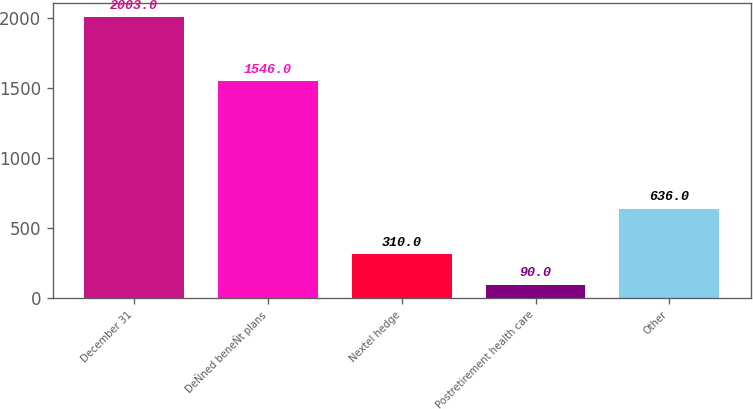Convert chart to OTSL. <chart><loc_0><loc_0><loc_500><loc_500><bar_chart><fcel>December 31<fcel>DeÑned beneÑt plans<fcel>Nextel hedge<fcel>Postretirement health care<fcel>Other<nl><fcel>2003<fcel>1546<fcel>310<fcel>90<fcel>636<nl></chart> 